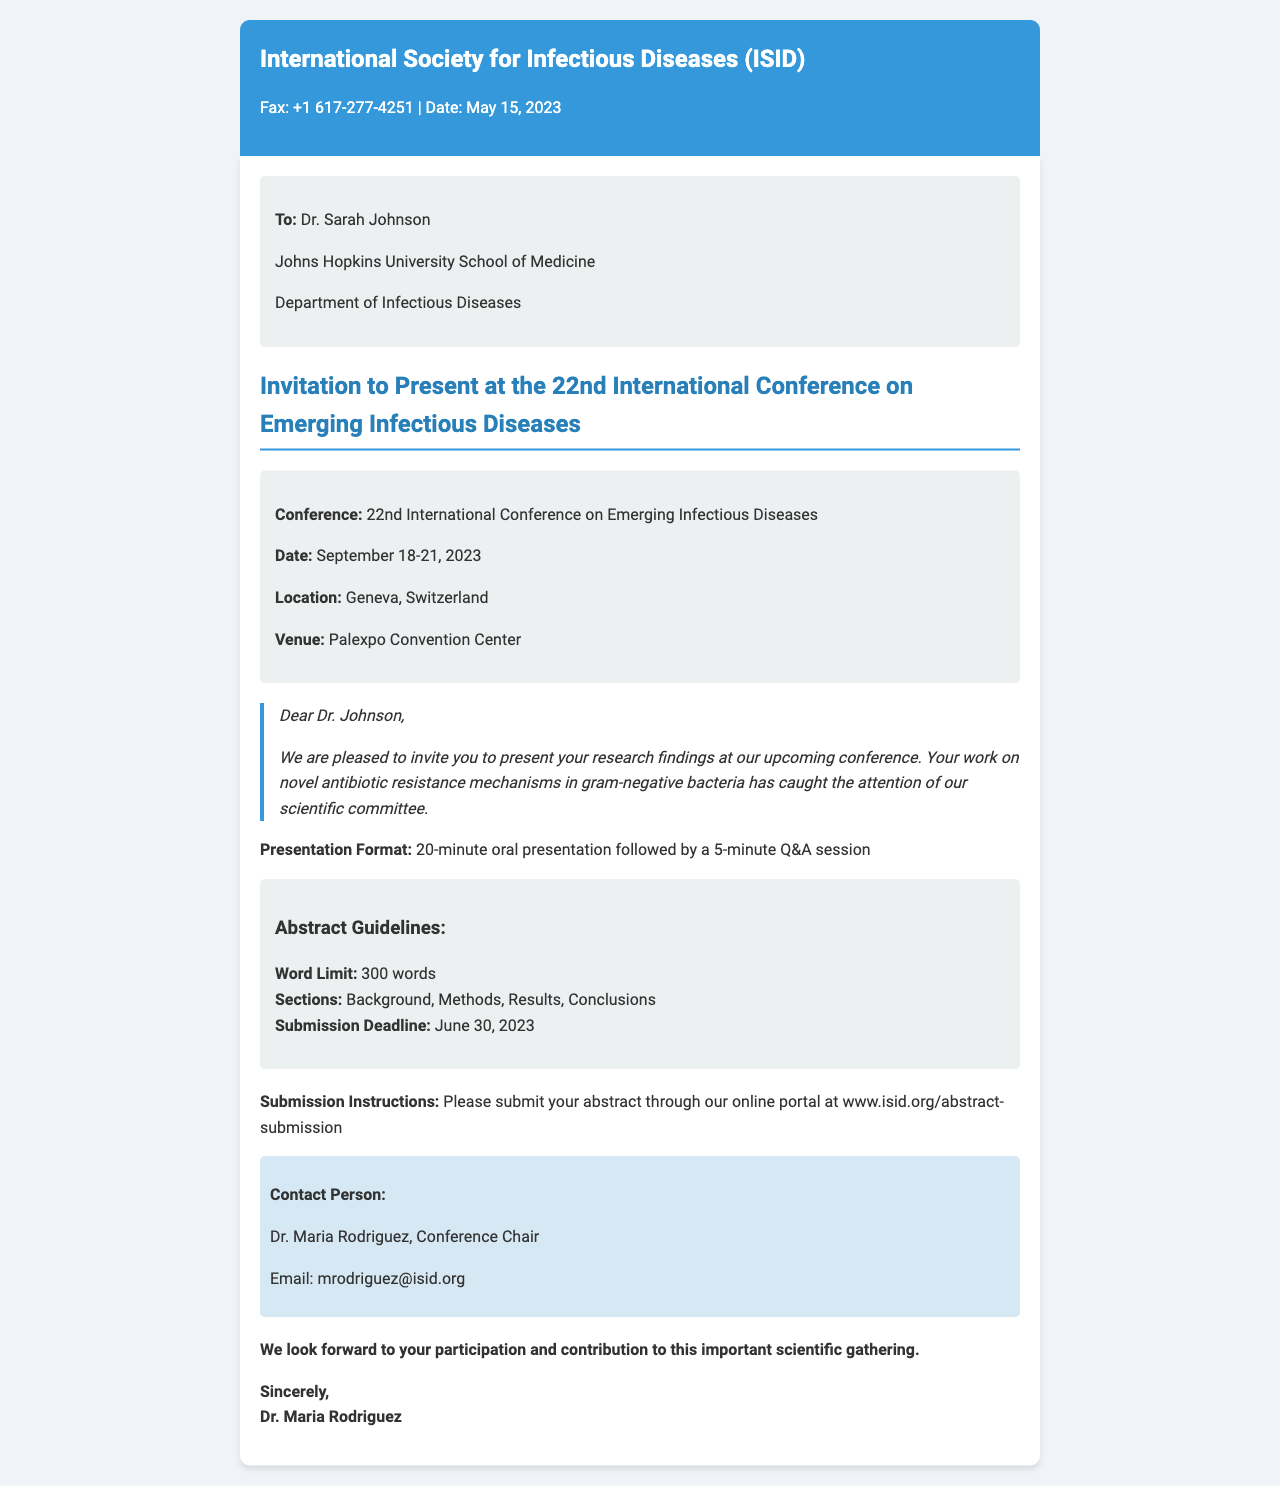What is the name of the conference? The conference is titled "22nd International Conference on Emerging Infectious Diseases."
Answer: 22nd International Conference on Emerging Infectious Diseases What is the submission deadline for abstracts? The document states the submission deadline is June 30, 2023.
Answer: June 30, 2023 Who is the contact person for the conference? The contact person's name is mentioned as Dr. Maria Rodriguez.
Answer: Dr. Maria Rodriguez What is the word limit for the abstract submission? The document specifies that the word limit for abstracts is 300 words.
Answer: 300 words How many minutes is the oral presentation allotted? The presentation format indicates a 20-minute oral presentation.
Answer: 20 minutes Where is the conference being held? The venue mentioned in the document is Palexpo Convention Center in Geneva, Switzerland.
Answer: Geneva, Switzerland What type of session follows the oral presentation? The document states that there will be a 5-minute Q&A session after the presentation.
Answer: 5-minute Q&A session What section type is included in the abstract guidelines? The abstract guidelines list "Background" as one of the sections.
Answer: Background What is the fax number provided in the document? The fax number given is +1 617-277-4251.
Answer: +1 617-277-4251 